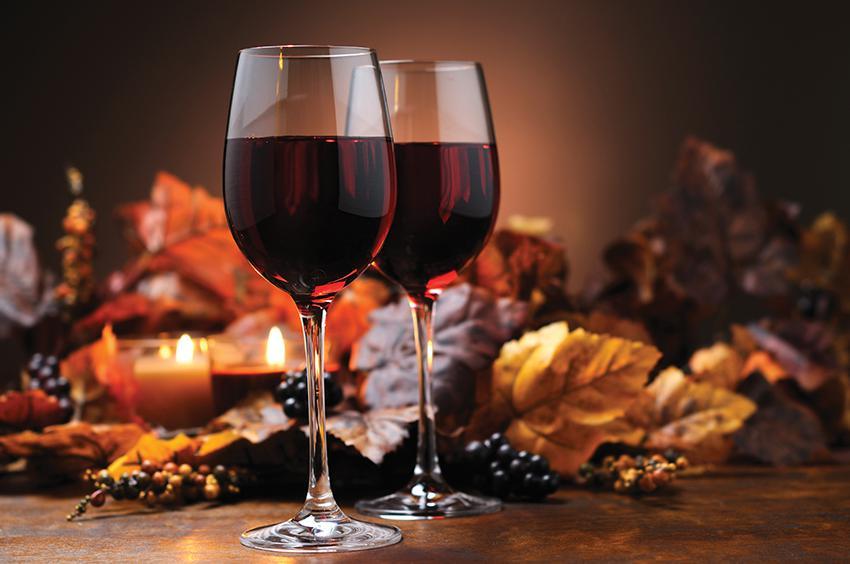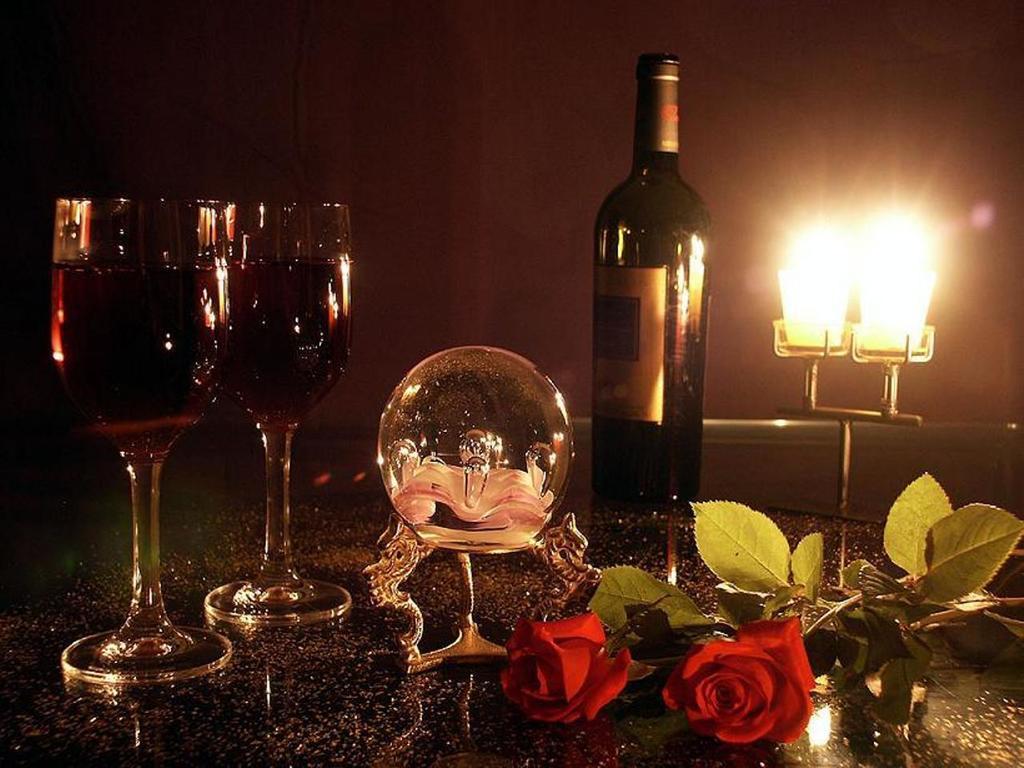The first image is the image on the left, the second image is the image on the right. Considering the images on both sides, is "there are four wine glasses total in both" valid? Answer yes or no. Yes. The first image is the image on the left, the second image is the image on the right. For the images shown, is this caption "There is an obvious fireplace in the background of one of the images." true? Answer yes or no. No. 